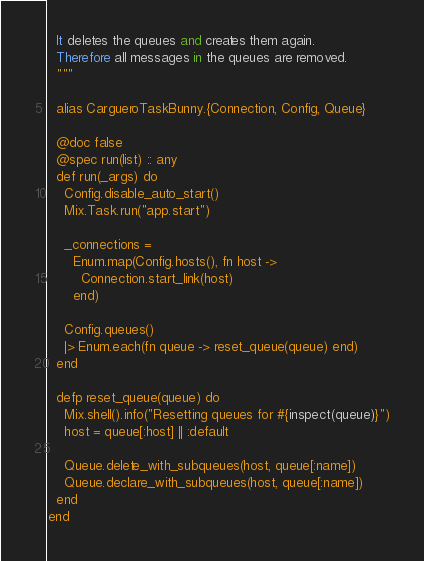<code> <loc_0><loc_0><loc_500><loc_500><_Elixir_>  It deletes the queues and creates them again.
  Therefore all messages in the queues are removed.
  """

  alias CargueroTaskBunny.{Connection, Config, Queue}

  @doc false
  @spec run(list) :: any
  def run(_args) do
    Config.disable_auto_start()
    Mix.Task.run("app.start")

    _connections =
      Enum.map(Config.hosts(), fn host ->
        Connection.start_link(host)
      end)

    Config.queues()
    |> Enum.each(fn queue -> reset_queue(queue) end)
  end

  defp reset_queue(queue) do
    Mix.shell().info("Resetting queues for #{inspect(queue)}")
    host = queue[:host] || :default

    Queue.delete_with_subqueues(host, queue[:name])
    Queue.declare_with_subqueues(host, queue[:name])
  end
end
</code> 